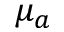<formula> <loc_0><loc_0><loc_500><loc_500>\mu _ { a }</formula> 